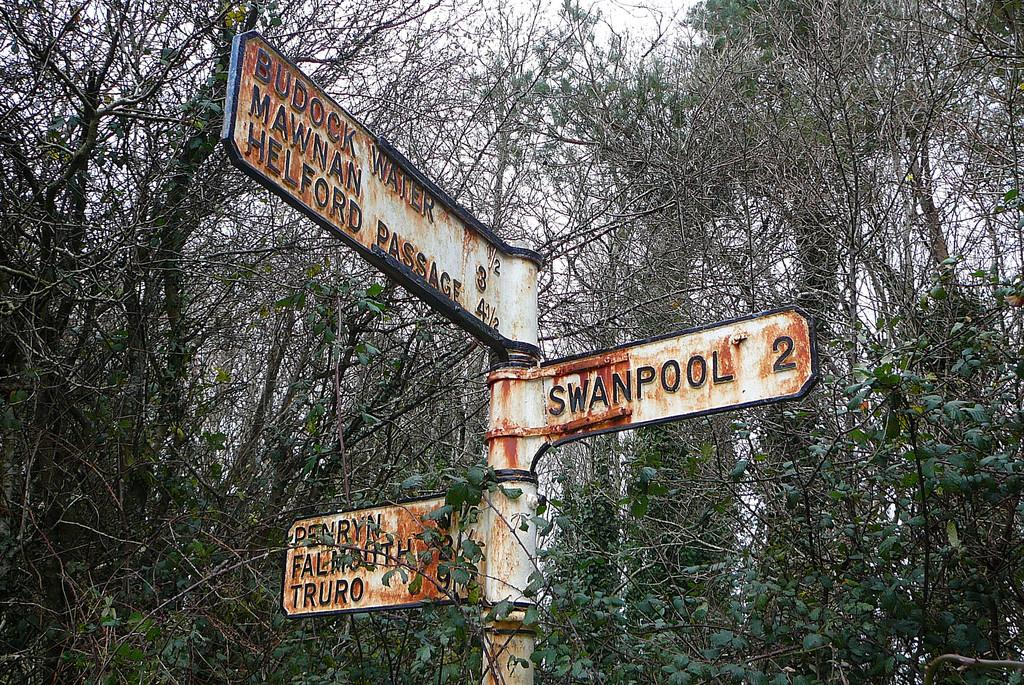What is the main object in the image? There is a pole with sign boards in the image. What can be seen in the background of the image? There are trees in the background of the image. Can you tell me what the father of the owl in the image is doing? There is no owl or its father present in the image. 